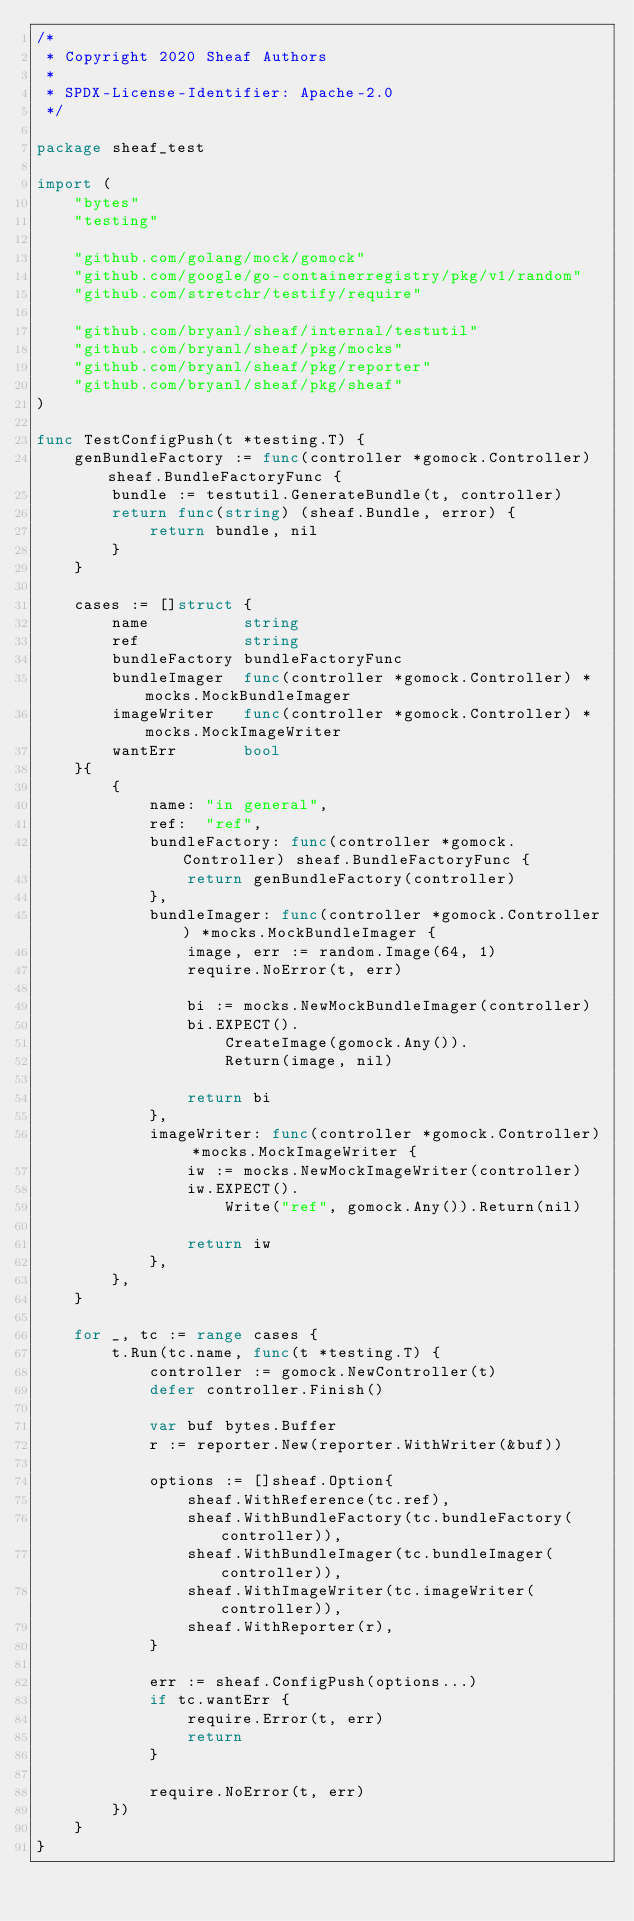<code> <loc_0><loc_0><loc_500><loc_500><_Go_>/*
 * Copyright 2020 Sheaf Authors
 *
 * SPDX-License-Identifier: Apache-2.0
 */

package sheaf_test

import (
	"bytes"
	"testing"

	"github.com/golang/mock/gomock"
	"github.com/google/go-containerregistry/pkg/v1/random"
	"github.com/stretchr/testify/require"

	"github.com/bryanl/sheaf/internal/testutil"
	"github.com/bryanl/sheaf/pkg/mocks"
	"github.com/bryanl/sheaf/pkg/reporter"
	"github.com/bryanl/sheaf/pkg/sheaf"
)

func TestConfigPush(t *testing.T) {
	genBundleFactory := func(controller *gomock.Controller) sheaf.BundleFactoryFunc {
		bundle := testutil.GenerateBundle(t, controller)
		return func(string) (sheaf.Bundle, error) {
			return bundle, nil
		}
	}

	cases := []struct {
		name          string
		ref           string
		bundleFactory bundleFactoryFunc
		bundleImager  func(controller *gomock.Controller) *mocks.MockBundleImager
		imageWriter   func(controller *gomock.Controller) *mocks.MockImageWriter
		wantErr       bool
	}{
		{
			name: "in general",
			ref:  "ref",
			bundleFactory: func(controller *gomock.Controller) sheaf.BundleFactoryFunc {
				return genBundleFactory(controller)
			},
			bundleImager: func(controller *gomock.Controller) *mocks.MockBundleImager {
				image, err := random.Image(64, 1)
				require.NoError(t, err)

				bi := mocks.NewMockBundleImager(controller)
				bi.EXPECT().
					CreateImage(gomock.Any()).
					Return(image, nil)

				return bi
			},
			imageWriter: func(controller *gomock.Controller) *mocks.MockImageWriter {
				iw := mocks.NewMockImageWriter(controller)
				iw.EXPECT().
					Write("ref", gomock.Any()).Return(nil)

				return iw
			},
		},
	}

	for _, tc := range cases {
		t.Run(tc.name, func(t *testing.T) {
			controller := gomock.NewController(t)
			defer controller.Finish()

			var buf bytes.Buffer
			r := reporter.New(reporter.WithWriter(&buf))

			options := []sheaf.Option{
				sheaf.WithReference(tc.ref),
				sheaf.WithBundleFactory(tc.bundleFactory(controller)),
				sheaf.WithBundleImager(tc.bundleImager(controller)),
				sheaf.WithImageWriter(tc.imageWriter(controller)),
				sheaf.WithReporter(r),
			}

			err := sheaf.ConfigPush(options...)
			if tc.wantErr {
				require.Error(t, err)
				return
			}

			require.NoError(t, err)
		})
	}
}
</code> 